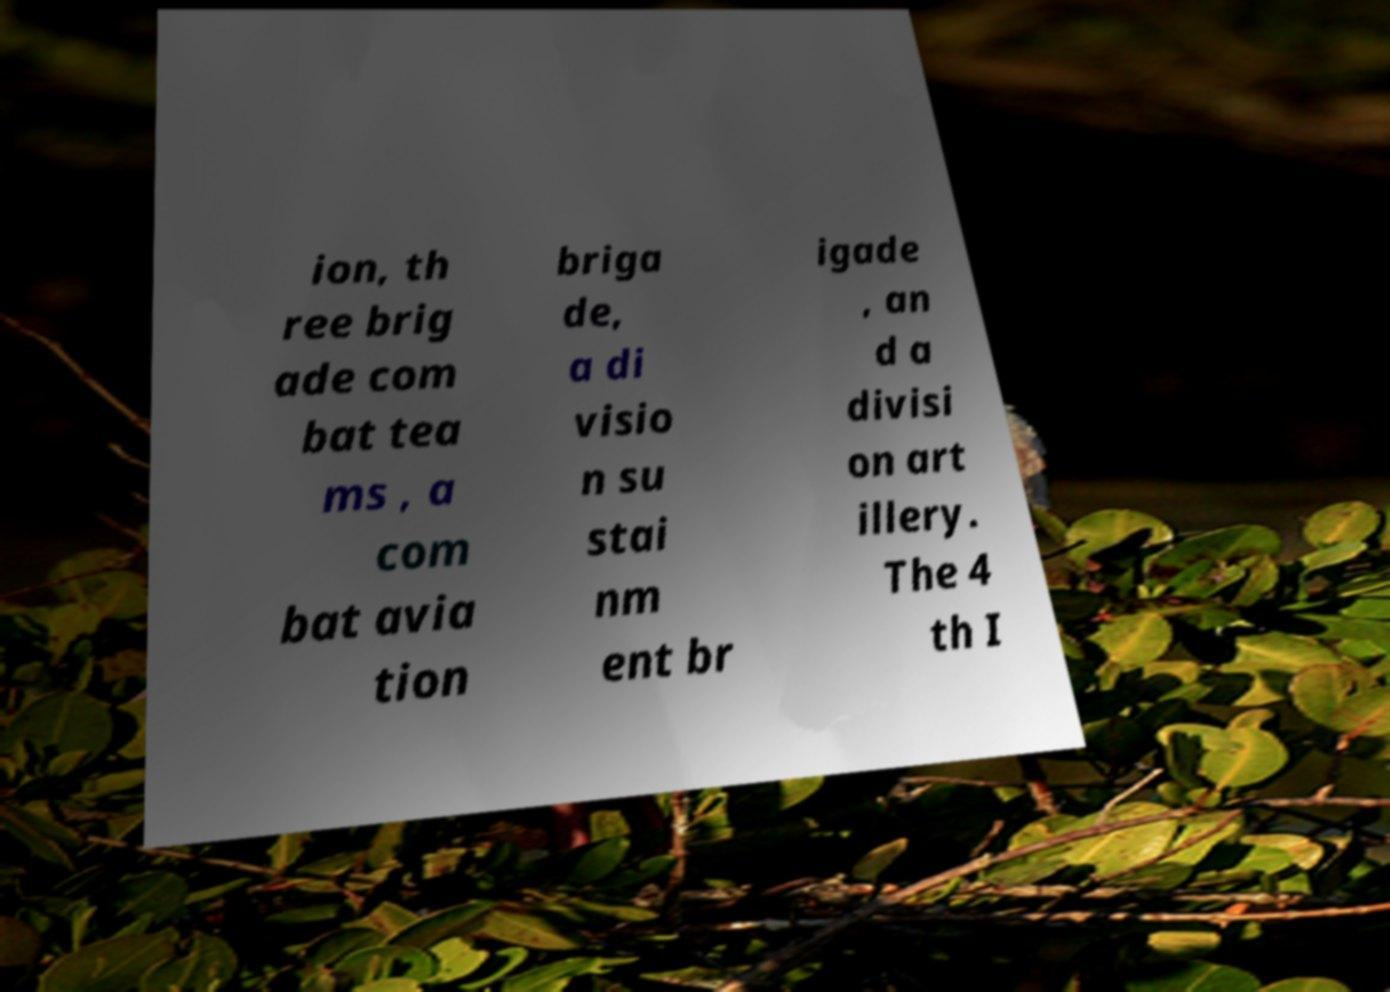Could you assist in decoding the text presented in this image and type it out clearly? ion, th ree brig ade com bat tea ms , a com bat avia tion briga de, a di visio n su stai nm ent br igade , an d a divisi on art illery. The 4 th I 